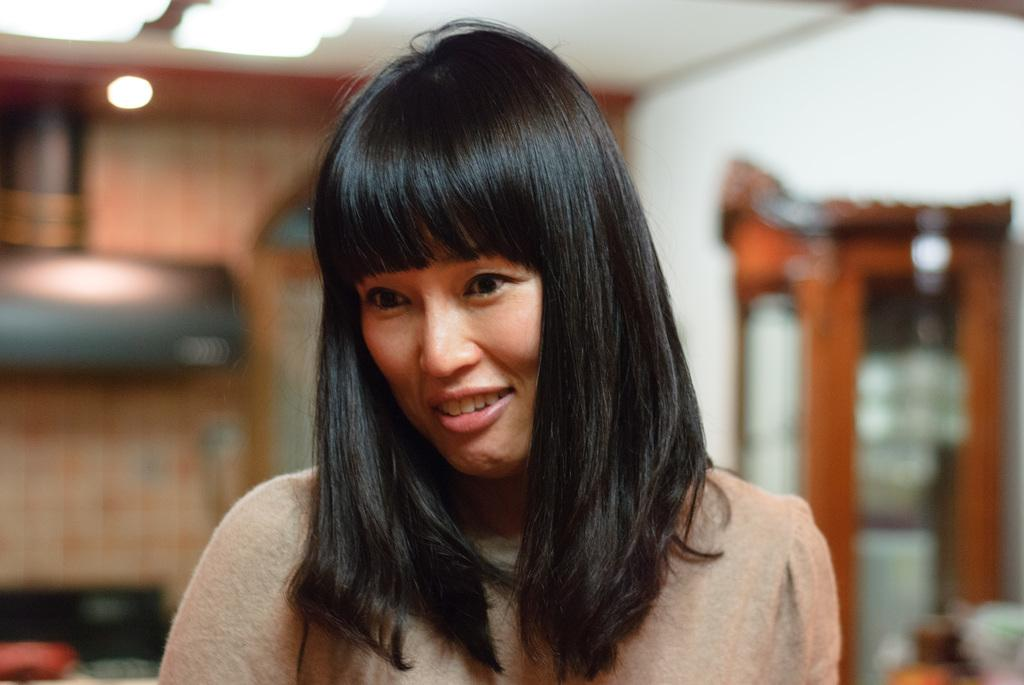Who is present in the image? There is a woman in the image. What can be seen in the background of the image? There is a wall and a door in the background of the image. What is visible at the top of the image? There are lights visible at the top of the image. What type of jewel is the woman wearing in the garden? There is no garden present in the image, and the woman is not wearing any jewel. 